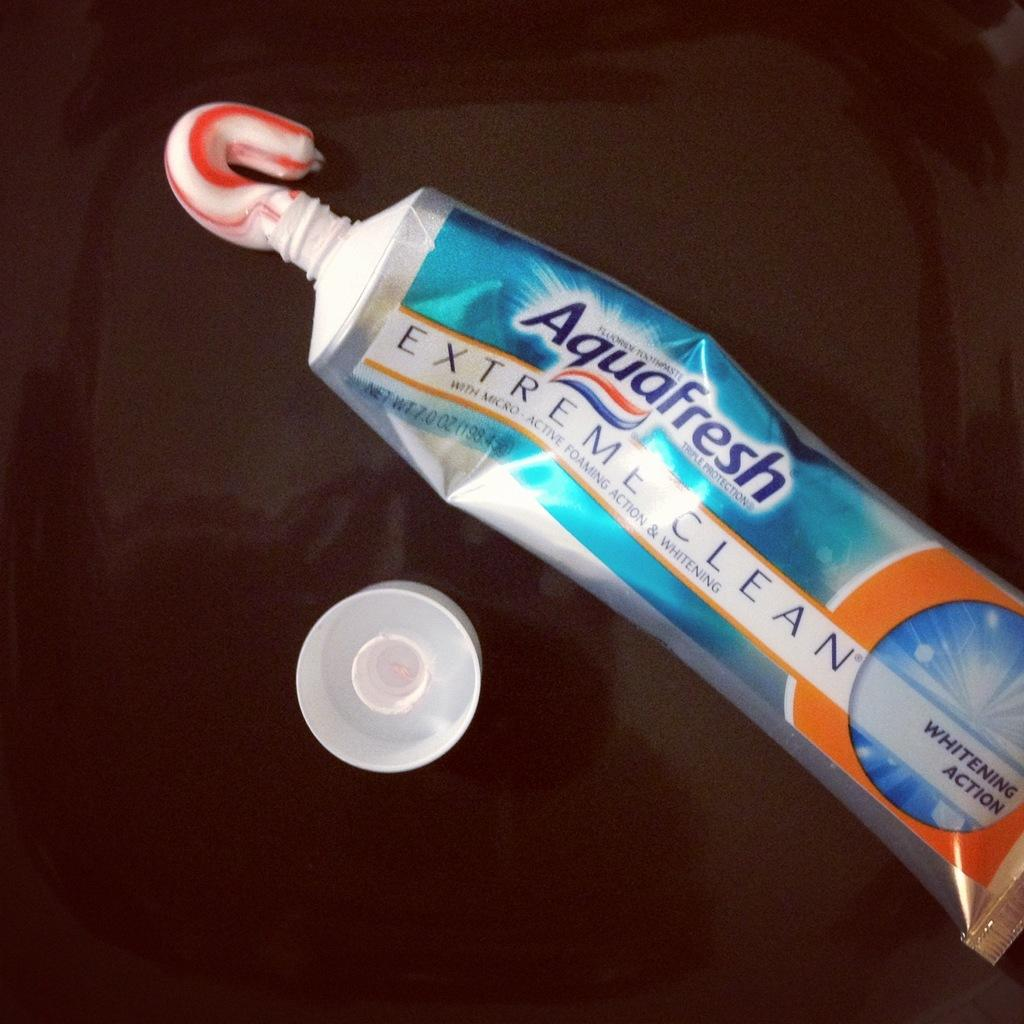<image>
Relay a brief, clear account of the picture shown. An open tube of Aquafresh toothpaste with some of it squeezed out. 